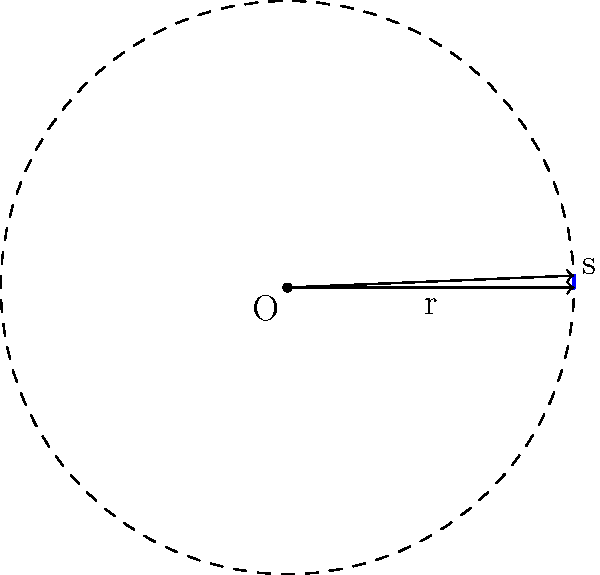У місцевому парку Києва є круглий фонтан радіусом 3 метри. Ви помітили, що один сектор фонтану потребує ремонту. Довжина дуги цього сектора становить 7.2 метри. Яка площа сектора, що потребує ремонту? Щоб знайти площу сектора, виконаємо наступні кроки:

1) Спочатку знайдемо центральний кут сектора. Для цього використаємо формулу довжини дуги:
   $s = r\theta$, де $s$ - довжина дуги, $r$ - радіус, $\theta$ - центральний кут у радіанах.

2) Підставимо відомі значення:
   $7.2 = 3\theta$

3) Розв'яжемо рівняння відносно $\theta$:
   $\theta = \frac{7.2}{3} = 2.4$ радіан

4) Тепер використаємо формулу площі сектора:
   $A = \frac{1}{2}r^2\theta$

5) Підставимо значення:
   $A = \frac{1}{2} \cdot 3^2 \cdot 2.4 = \frac{1}{2} \cdot 9 \cdot 2.4 = 10.8$

Отже, площа сектора, що потребує ремонту, становить 10.8 квадратних метрів.
Answer: 10.8 м² 